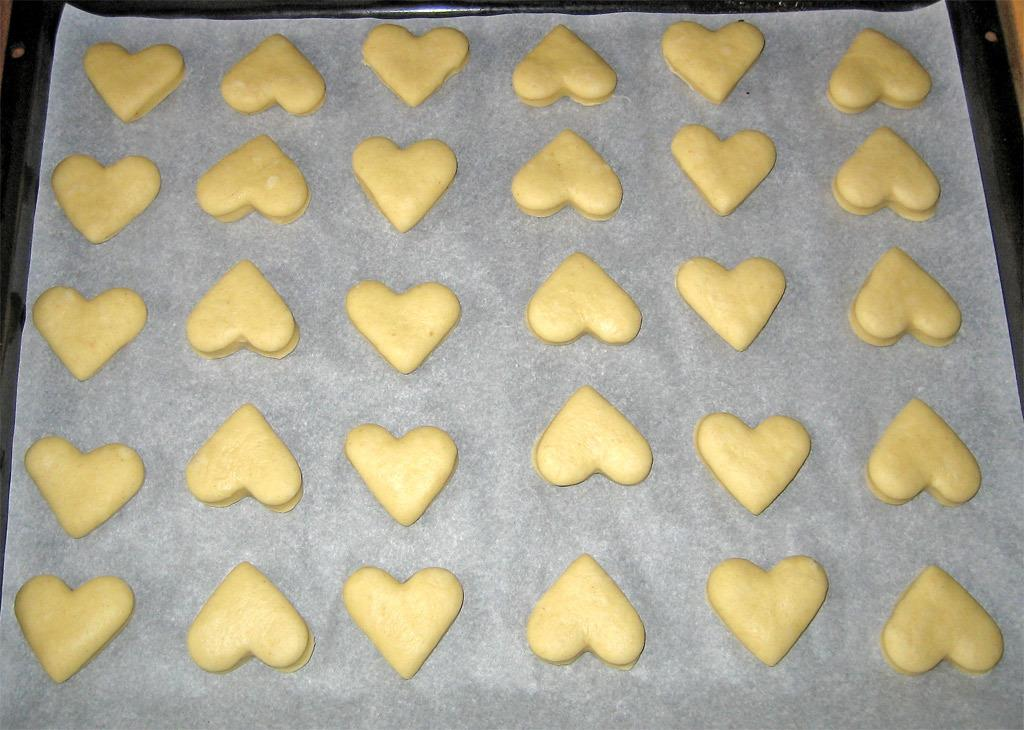What is present on the tray in the image? There is a butter paper on the tray. What is placed on the butter paper? The cookie dough is in the shape of a heart and is placed on the butter paper. What is the current state of the cookie dough? The cookie dough is ready to bake. How many twigs are used to support the window in the image? There is no window or twigs present in the image. 